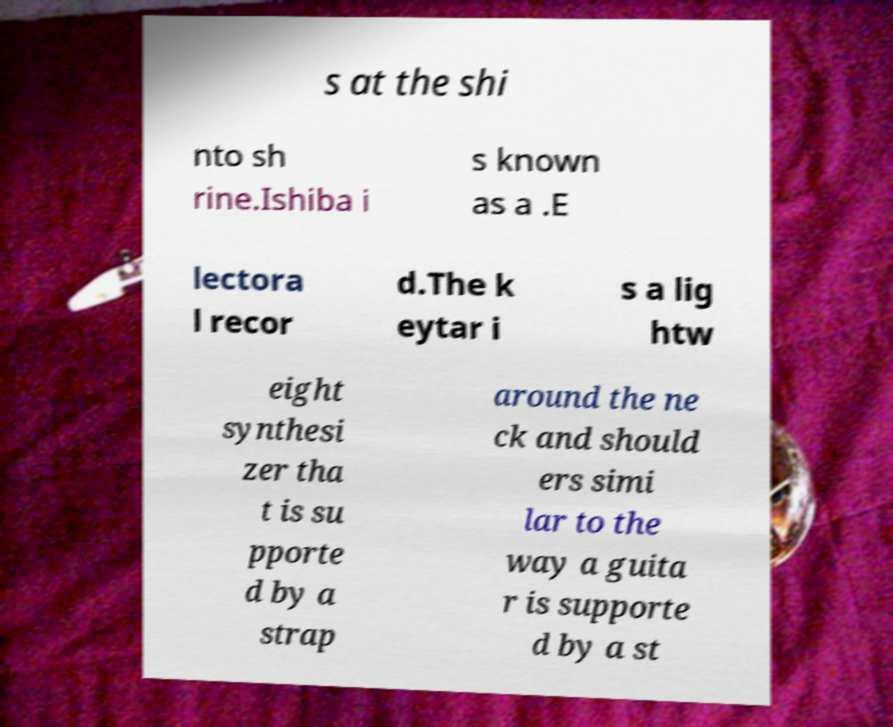Please read and relay the text visible in this image. What does it say? s at the shi nto sh rine.Ishiba i s known as a .E lectora l recor d.The k eytar i s a lig htw eight synthesi zer tha t is su pporte d by a strap around the ne ck and should ers simi lar to the way a guita r is supporte d by a st 